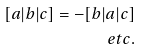<formula> <loc_0><loc_0><loc_500><loc_500>[ a | b | c ] = - [ b | a | c ] \\ e t c .</formula> 